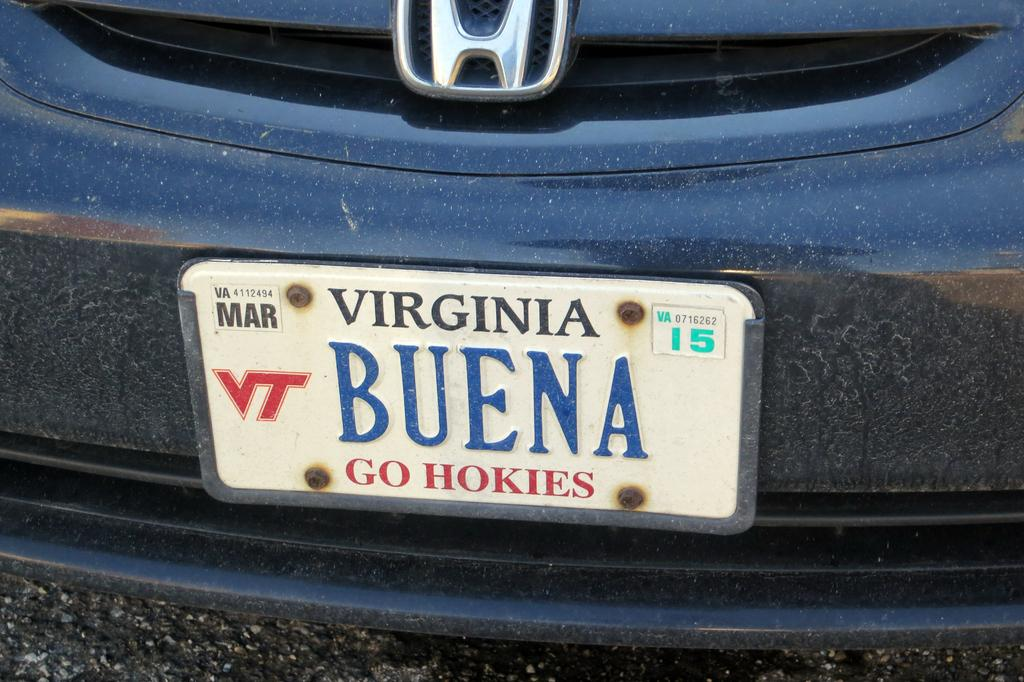<image>
Relay a brief, clear account of the picture shown. A blue honda car with a Virginia Buena Go Hokies license plate. 